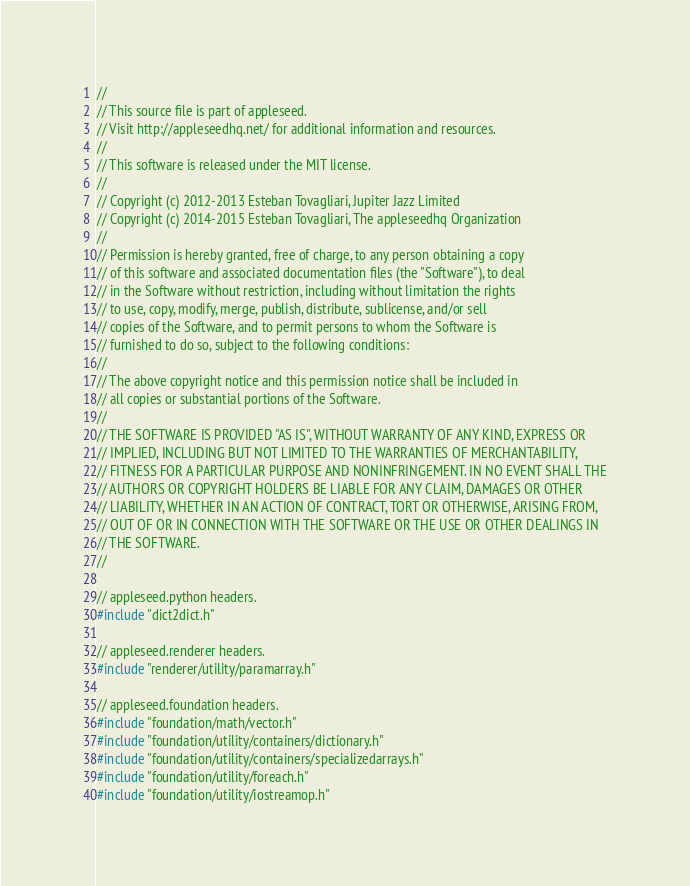Convert code to text. <code><loc_0><loc_0><loc_500><loc_500><_C++_>
//
// This source file is part of appleseed.
// Visit http://appleseedhq.net/ for additional information and resources.
//
// This software is released under the MIT license.
//
// Copyright (c) 2012-2013 Esteban Tovagliari, Jupiter Jazz Limited
// Copyright (c) 2014-2015 Esteban Tovagliari, The appleseedhq Organization
//
// Permission is hereby granted, free of charge, to any person obtaining a copy
// of this software and associated documentation files (the "Software"), to deal
// in the Software without restriction, including without limitation the rights
// to use, copy, modify, merge, publish, distribute, sublicense, and/or sell
// copies of the Software, and to permit persons to whom the Software is
// furnished to do so, subject to the following conditions:
//
// The above copyright notice and this permission notice shall be included in
// all copies or substantial portions of the Software.
//
// THE SOFTWARE IS PROVIDED "AS IS", WITHOUT WARRANTY OF ANY KIND, EXPRESS OR
// IMPLIED, INCLUDING BUT NOT LIMITED TO THE WARRANTIES OF MERCHANTABILITY,
// FITNESS FOR A PARTICULAR PURPOSE AND NONINFRINGEMENT. IN NO EVENT SHALL THE
// AUTHORS OR COPYRIGHT HOLDERS BE LIABLE FOR ANY CLAIM, DAMAGES OR OTHER
// LIABILITY, WHETHER IN AN ACTION OF CONTRACT, TORT OR OTHERWISE, ARISING FROM,
// OUT OF OR IN CONNECTION WITH THE SOFTWARE OR THE USE OR OTHER DEALINGS IN
// THE SOFTWARE.
//

// appleseed.python headers.
#include "dict2dict.h"

// appleseed.renderer headers.
#include "renderer/utility/paramarray.h"

// appleseed.foundation headers.
#include "foundation/math/vector.h"
#include "foundation/utility/containers/dictionary.h"
#include "foundation/utility/containers/specializedarrays.h"
#include "foundation/utility/foreach.h"
#include "foundation/utility/iostreamop.h"</code> 